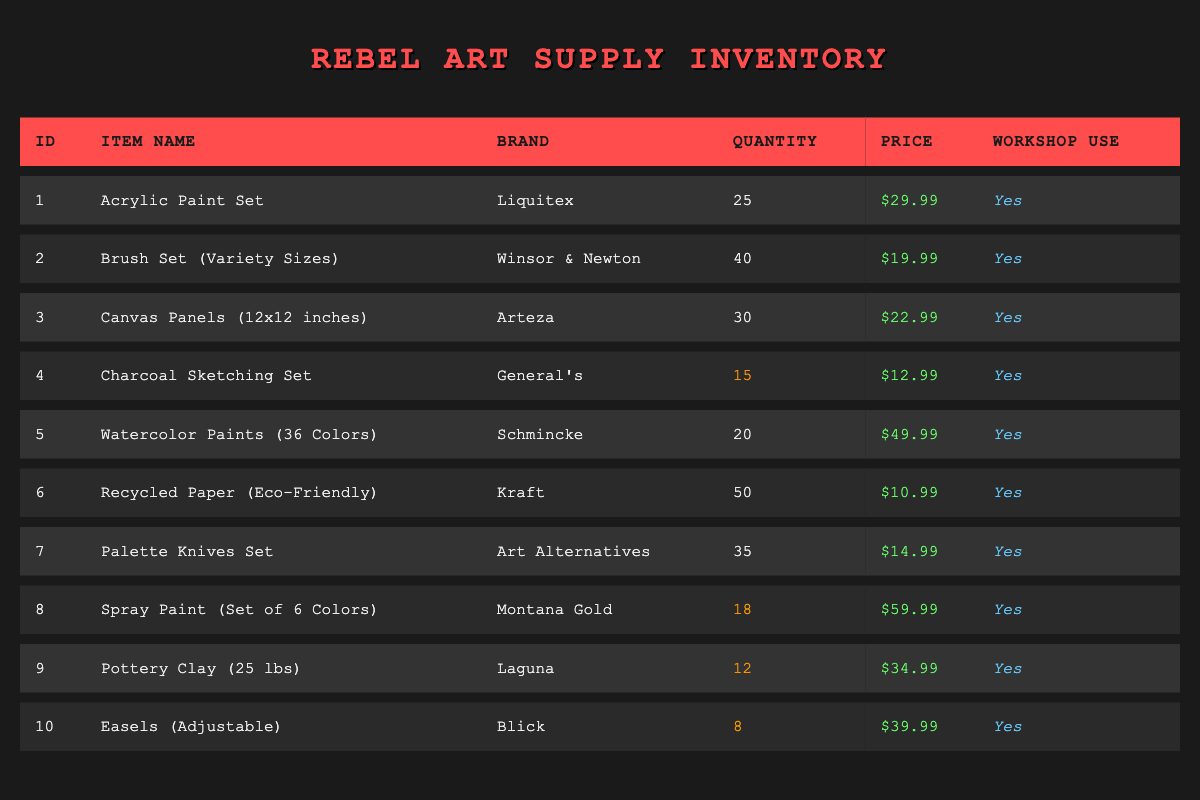What is the total quantity of acrylic paint sets available? The inventory shows that there are 25 acrylic paint sets in stock, as listed in the quantity column for that item.
Answer: 25 Which item has the highest price per unit? By examining the price per unit for each item, the watercolor paints are priced at $49.99, which is the highest among all items listed.
Answer: Watercolor Paints (36 Colors) How many items in the inventory are suitable for community workshop use? All listed items indicate "Yes" in the workshop use column. Therefore, all 10 items are designated for community workshops.
Answer: 10 Is there any item in low stock? The stock levels of several items are highlighted in the table; the charcoal sketching set (15), spray paint (18), pottery clay (12), and easels (8) are marked low stock.
Answer: Yes What is the total price of the pottery clay and the easels combined? The price of pottery clay is $34.99, and the easels are $39.99. Adding these gives: 34.99 + 39.99 = 74.98.
Answer: 74.98 What is the average price of all items listed? To find the average price, we sum the prices: (29.99 + 19.99 + 22.99 + 12.99 + 49.99 + 10.99 + 14.99 + 59.99 + 34.99 + 39.99) =  303.90, then divide by the count of items (10): 303.90 / 10 = 30.39.
Answer: 30.39 How many brush sets are in stock compared to the total number of available easels? There are 40 brush sets and 8 easels in stock. Thus, brush sets are more abundant than easels: 40 (brush sets) > 8 (easels).
Answer: Brush sets are more abundant Which brand supplies the most items in stock? By comparing inventory levels, Kraft supplies recycled paper, which has the highest quantity at 50 items. Other brands have less stock in their respective categories.
Answer: Kraft 